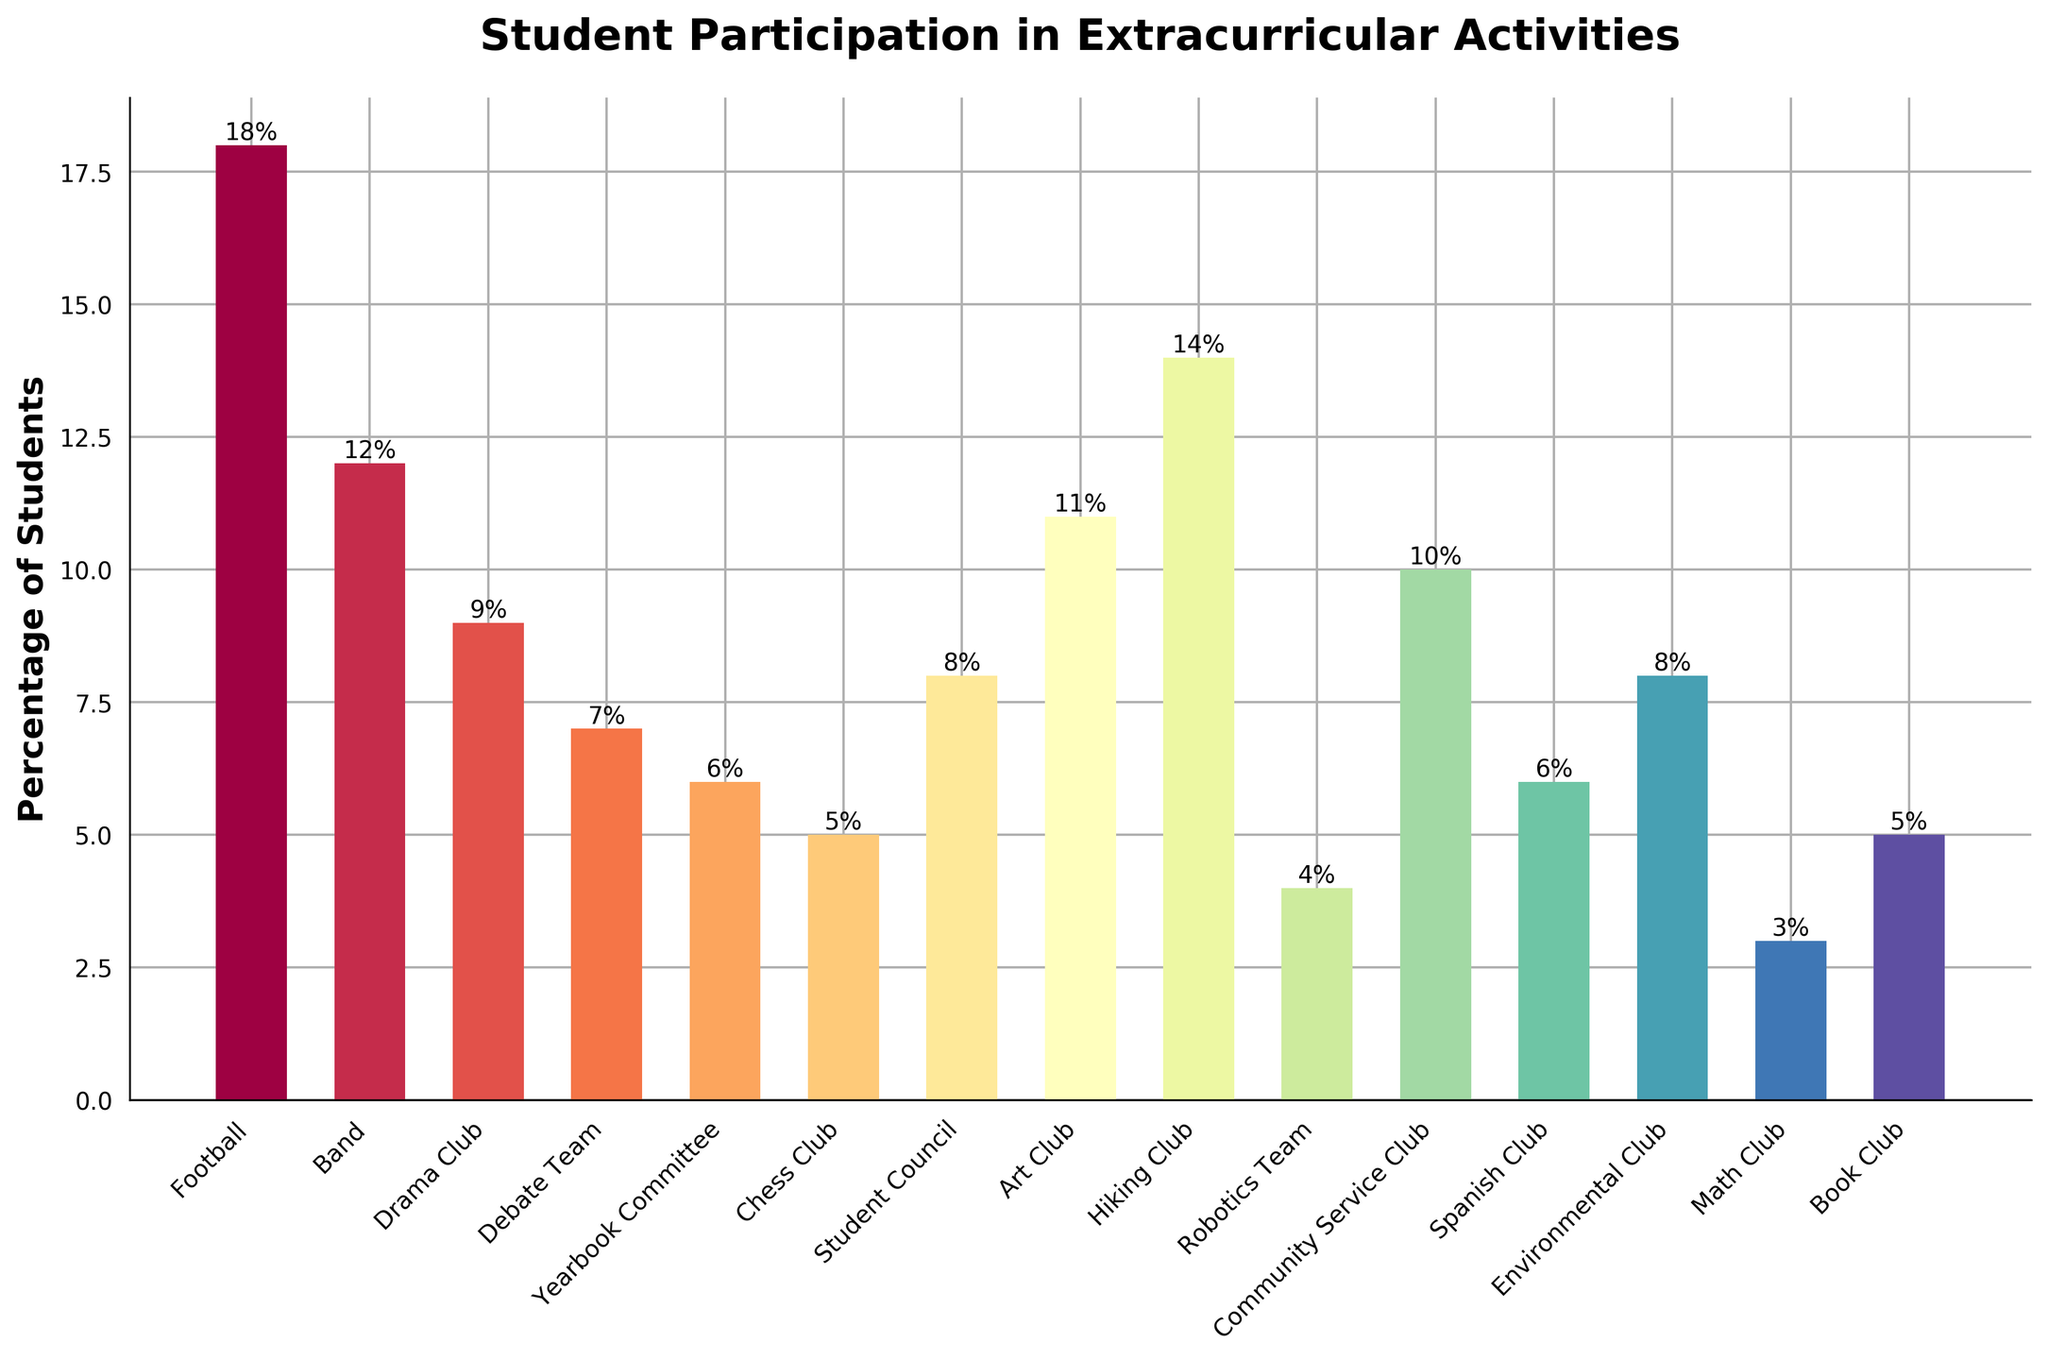How many activities have a student participation rate higher than 10%? Identify which bars in the chart are taller than the 10% mark. Count those activities: Football (18%), Band (12%), Hiking Club (14%), and Art Club (11%)
Answer: 4 Which activity has the lowest student participation rate? Locate the shortest bar in the chart. Math Club has the shortest bar with a height of 3%
Answer: Math Club What is the combined participation percentage for Football and Band? Sum the percentages of Football (18%) and Band (12%), 18 + 12
Answer: 30% Is the participation rate in Drama Club higher than in Debate Team? Compare the heights of the bars for Drama Club and Debate Team. Drama Club (9%) is higher than Debate Team (7%)
Answer: Yes Which activity has a higher participation rate: Student Council or Spanish Club? Compare the heights of the bars for Student Council (8%) and Spanish Club (6%)
Answer: Student Council What is the total percentage of students involved in Book Club and Chess Club? Add the participation rates of Book Club (5%) and Chess Club (5%), 5 + 5
Answer: 10% Are there more students participating in Art Club or Community Service Club? Compare the heights of the bars for Art Club (11%) and Community Service Club (10%)
Answer: Art Club What is the difference in participation rates between Football and Robotics Team? Subtract the percentage of Robotics Team (4%) from the percentage of Football (18%), 18 - 4
Answer: 14% What is the average participation rate for the following activities: Chess Club, Yearbook Committee, Spanish Club, and Environmental Club? Sum the participation rates of these activities: Chess Club (5%), Yearbook Committee (6%), Spanish Club (6%), and Environmental Club (8%), then divide by the number of activities, (5 + 6 + 6 + 8) / 4
Answer: 6.25% Which clubs have equal participation rates? Identify bars with the same height. Chess Club and Book Club both have 5%, Yearbook Committee and Spanish Club both have 6%, Environmental Club and Student Council both have 8%
Answer: Chess Club & Book Club, Yearbook Committee & Spanish Club, Environmental Club & Student Council 